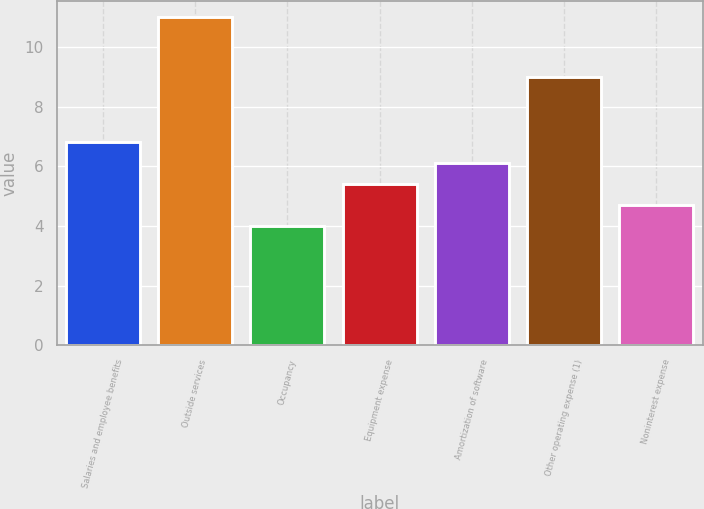<chart> <loc_0><loc_0><loc_500><loc_500><bar_chart><fcel>Salaries and employee benefits<fcel>Outside services<fcel>Occupancy<fcel>Equipment expense<fcel>Amortization of software<fcel>Other operating expense (1)<fcel>Noninterest expense<nl><fcel>6.8<fcel>11<fcel>4<fcel>5.4<fcel>6.1<fcel>9<fcel>4.7<nl></chart> 